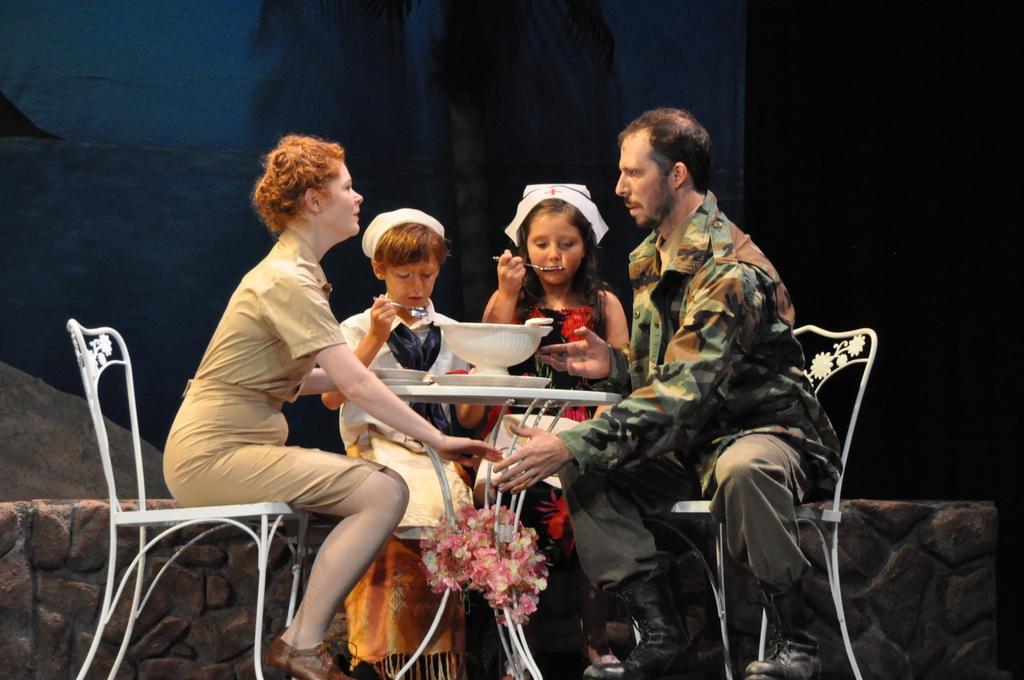Could you give a brief overview of what you see in this image? On the left side a woman is sitting on chair. On the right side man wearing boots is sitting on a chair. Two children wearing caps are sitting in the back. There is a table in front of them. On the table there are plates and a vessel. On the stands of the table there are flowers. In the background there is a wall. Two children are holding spoon. Children are sitting on a stone wall. 